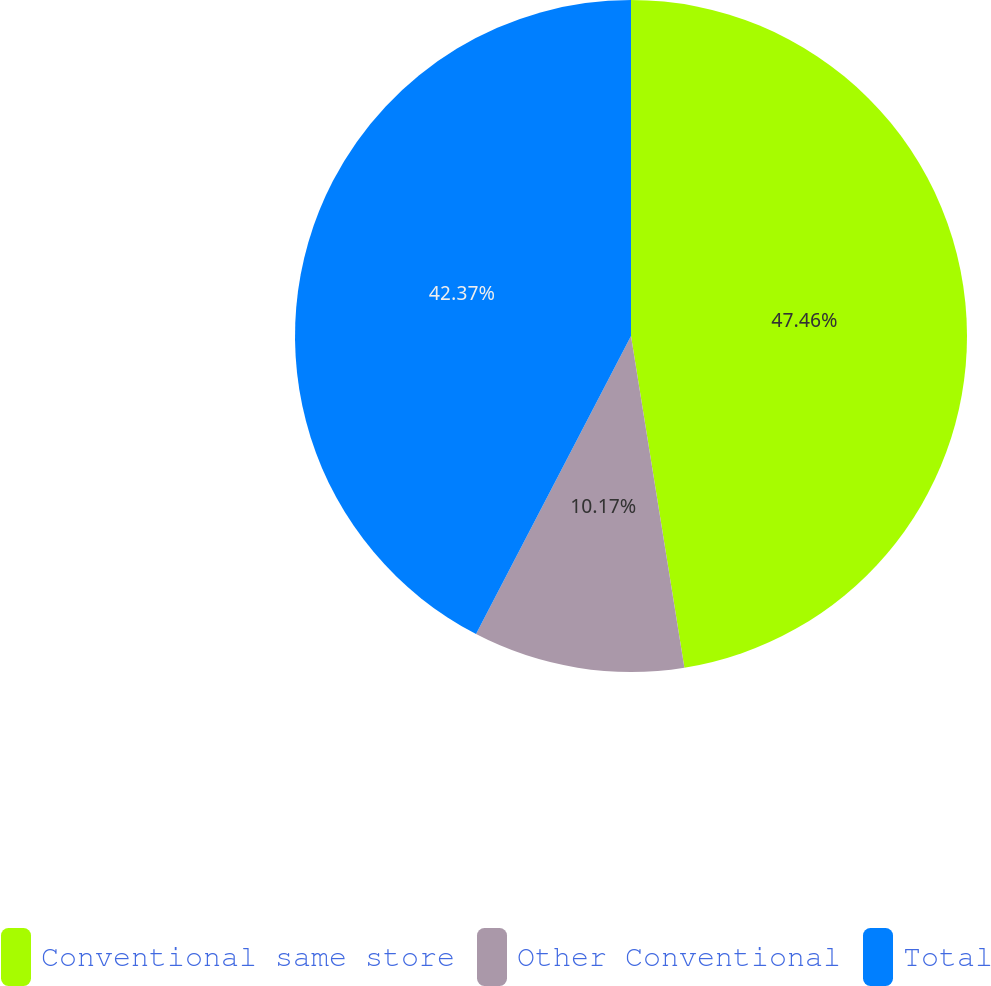Convert chart to OTSL. <chart><loc_0><loc_0><loc_500><loc_500><pie_chart><fcel>Conventional same store<fcel>Other Conventional<fcel>Total<nl><fcel>47.46%<fcel>10.17%<fcel>42.37%<nl></chart> 